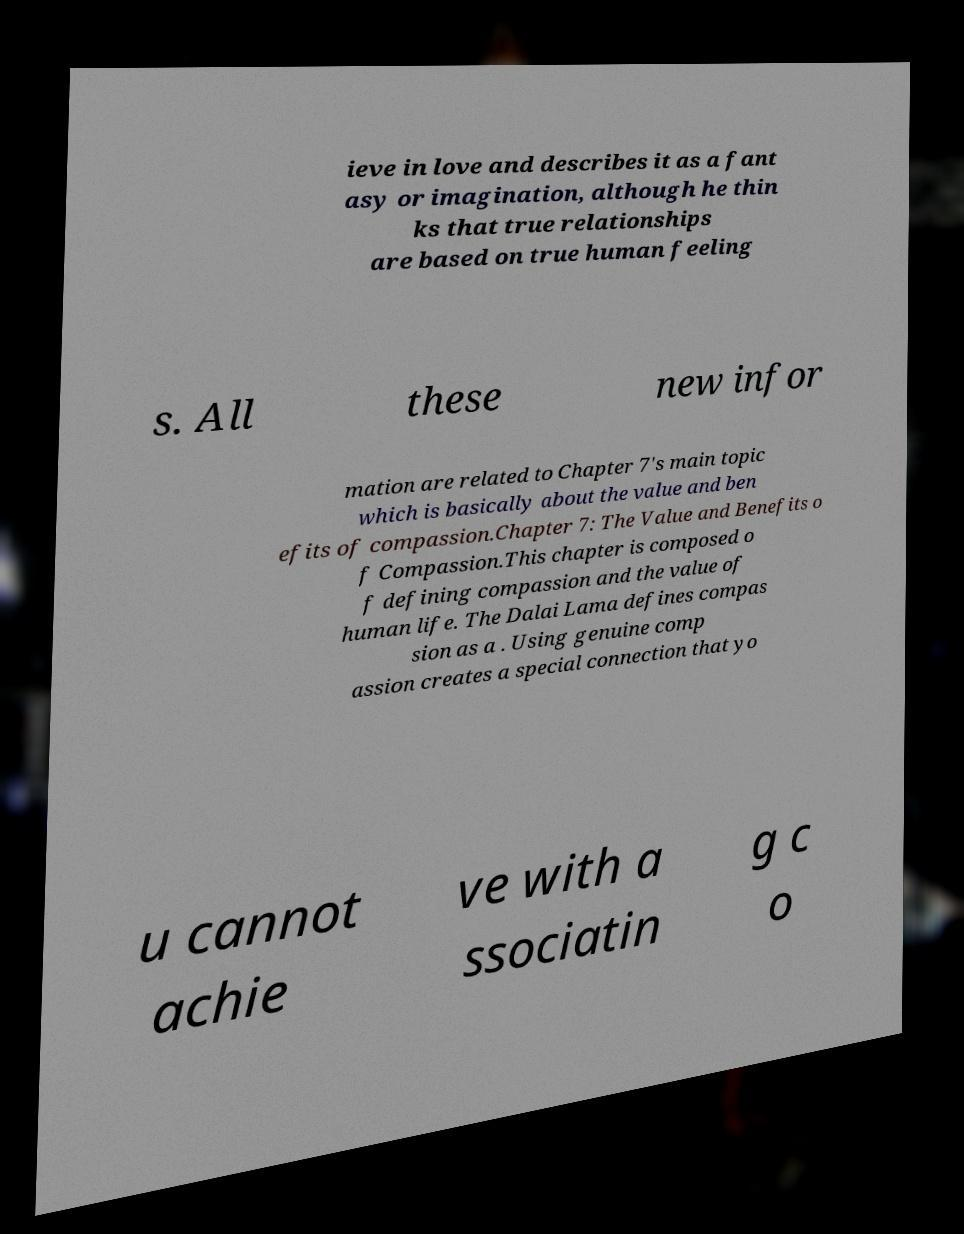Could you assist in decoding the text presented in this image and type it out clearly? ieve in love and describes it as a fant asy or imagination, although he thin ks that true relationships are based on true human feeling s. All these new infor mation are related to Chapter 7's main topic which is basically about the value and ben efits of compassion.Chapter 7: The Value and Benefits o f Compassion.This chapter is composed o f defining compassion and the value of human life. The Dalai Lama defines compas sion as a . Using genuine comp assion creates a special connection that yo u cannot achie ve with a ssociatin g c o 